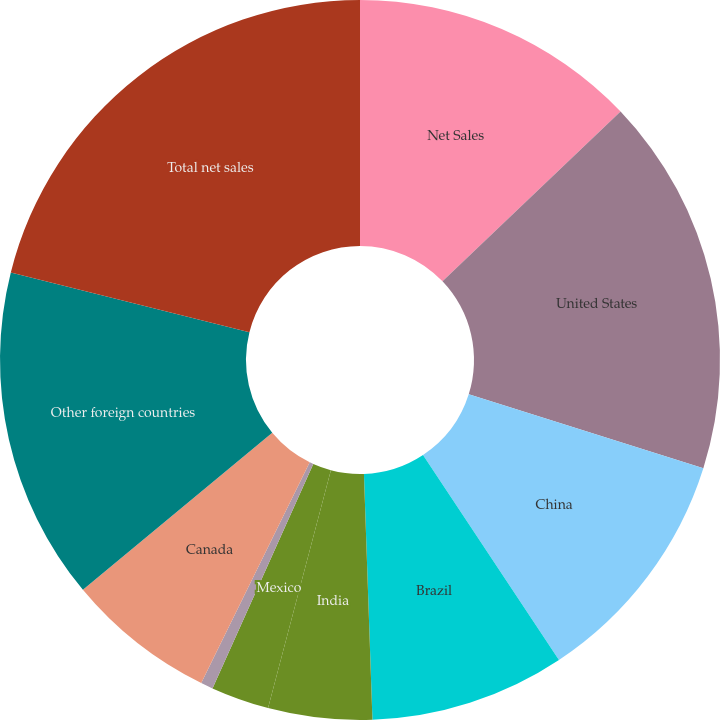<chart> <loc_0><loc_0><loc_500><loc_500><pie_chart><fcel>Net Sales<fcel>United States<fcel>China<fcel>Brazil<fcel>India<fcel>Mexico<fcel>United Kingdom<fcel>Canada<fcel>Other foreign countries<fcel>Total net sales<nl><fcel>12.88%<fcel>16.98%<fcel>10.82%<fcel>8.77%<fcel>4.66%<fcel>2.61%<fcel>0.55%<fcel>6.71%<fcel>14.93%<fcel>21.09%<nl></chart> 